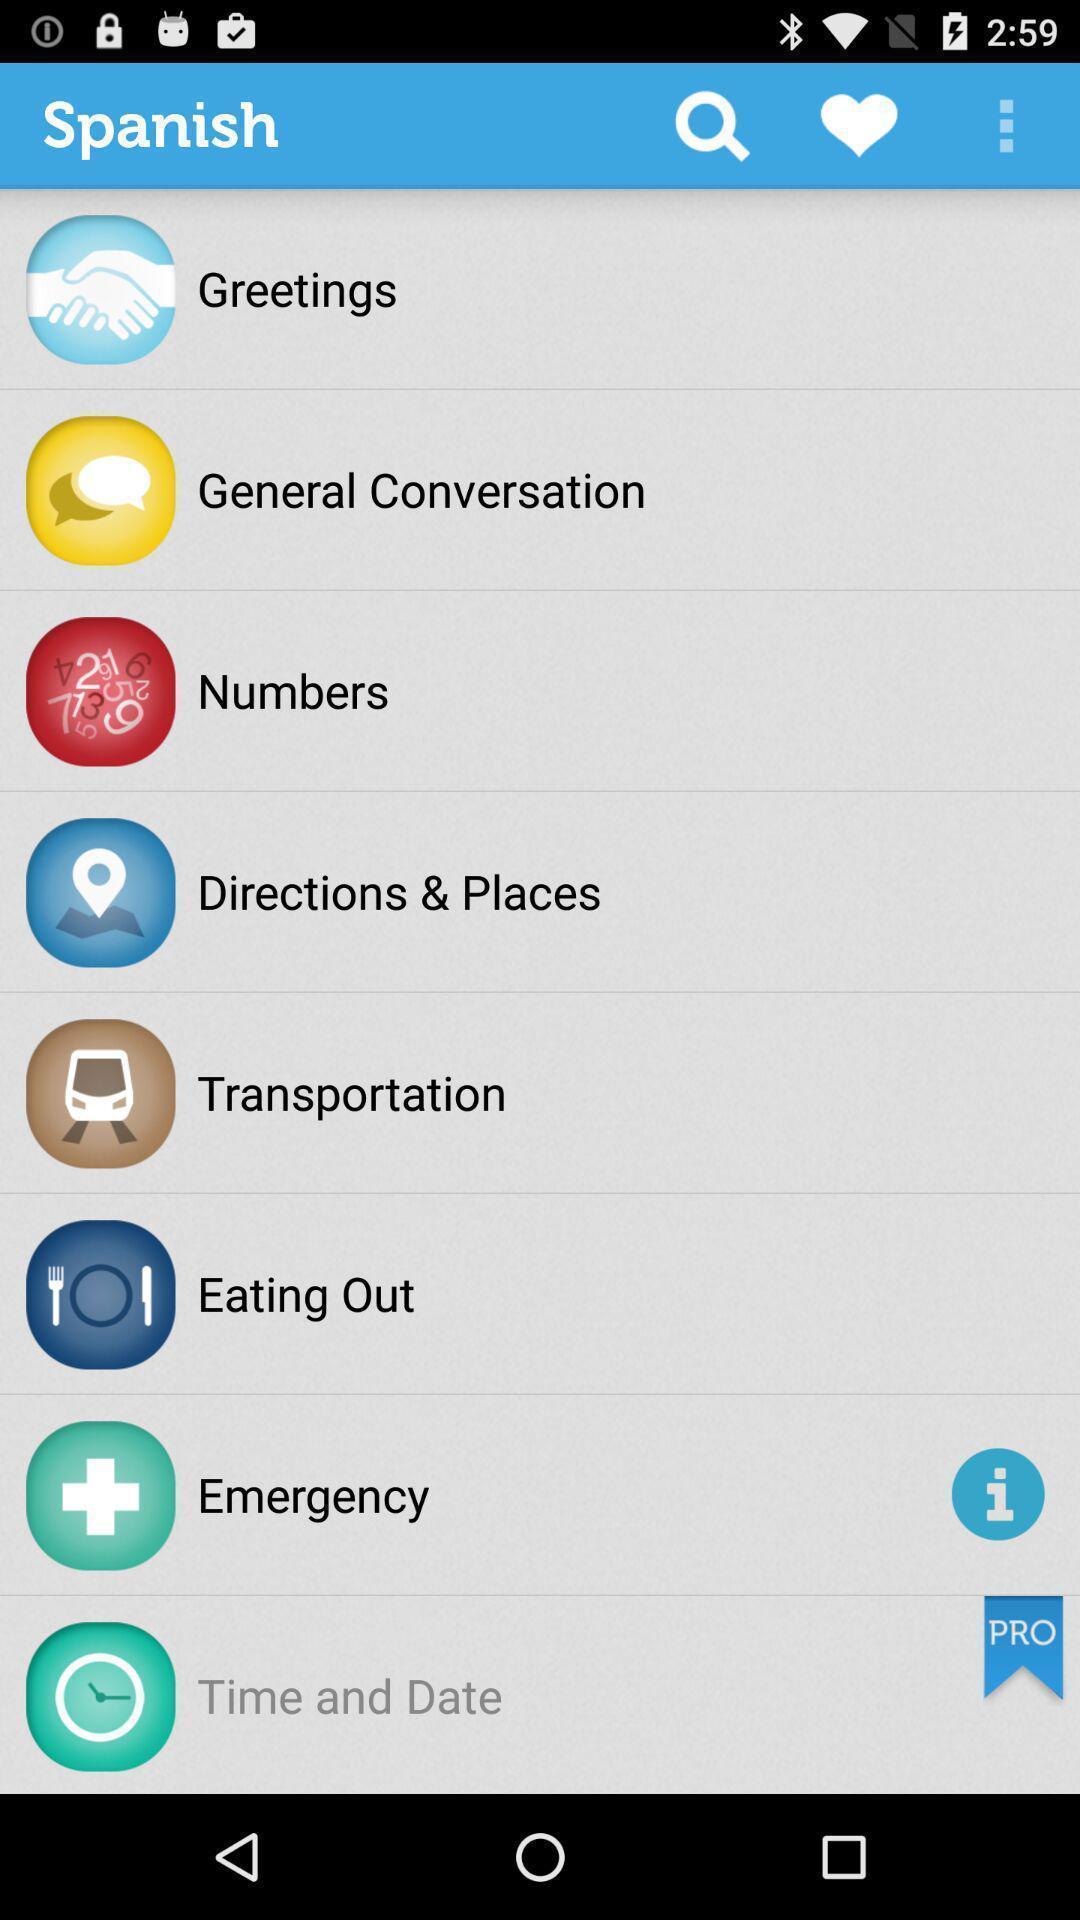Explain the elements present in this screenshot. Screen shows different options in learning language app. 